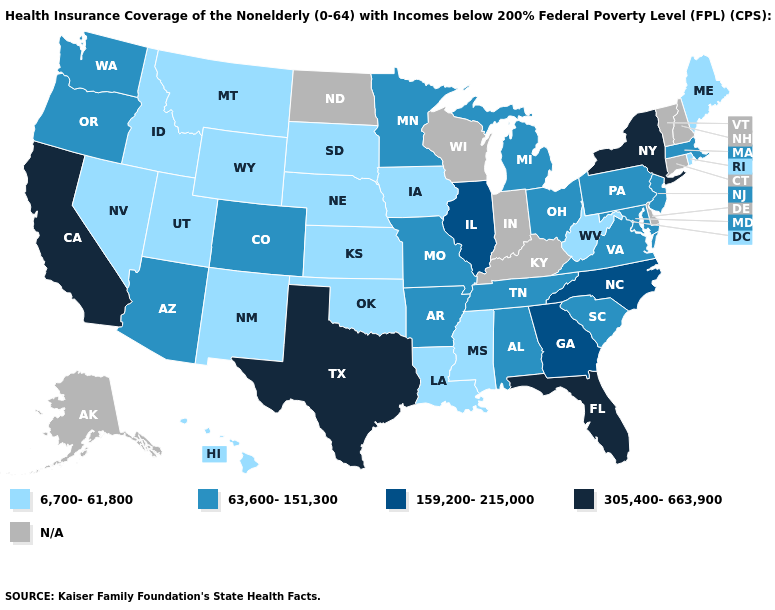Does Rhode Island have the highest value in the Northeast?
Be succinct. No. What is the value of Vermont?
Short answer required. N/A. Which states have the lowest value in the USA?
Concise answer only. Hawaii, Idaho, Iowa, Kansas, Louisiana, Maine, Mississippi, Montana, Nebraska, Nevada, New Mexico, Oklahoma, Rhode Island, South Dakota, Utah, West Virginia, Wyoming. What is the value of Mississippi?
Be succinct. 6,700-61,800. Among the states that border New Jersey , which have the lowest value?
Answer briefly. Pennsylvania. Name the states that have a value in the range 6,700-61,800?
Concise answer only. Hawaii, Idaho, Iowa, Kansas, Louisiana, Maine, Mississippi, Montana, Nebraska, Nevada, New Mexico, Oklahoma, Rhode Island, South Dakota, Utah, West Virginia, Wyoming. Does the map have missing data?
Keep it brief. Yes. Does Texas have the highest value in the USA?
Give a very brief answer. Yes. What is the lowest value in the MidWest?
Short answer required. 6,700-61,800. Name the states that have a value in the range 63,600-151,300?
Short answer required. Alabama, Arizona, Arkansas, Colorado, Maryland, Massachusetts, Michigan, Minnesota, Missouri, New Jersey, Ohio, Oregon, Pennsylvania, South Carolina, Tennessee, Virginia, Washington. Is the legend a continuous bar?
Answer briefly. No. What is the value of Virginia?
Be succinct. 63,600-151,300. What is the value of Nebraska?
Write a very short answer. 6,700-61,800. 